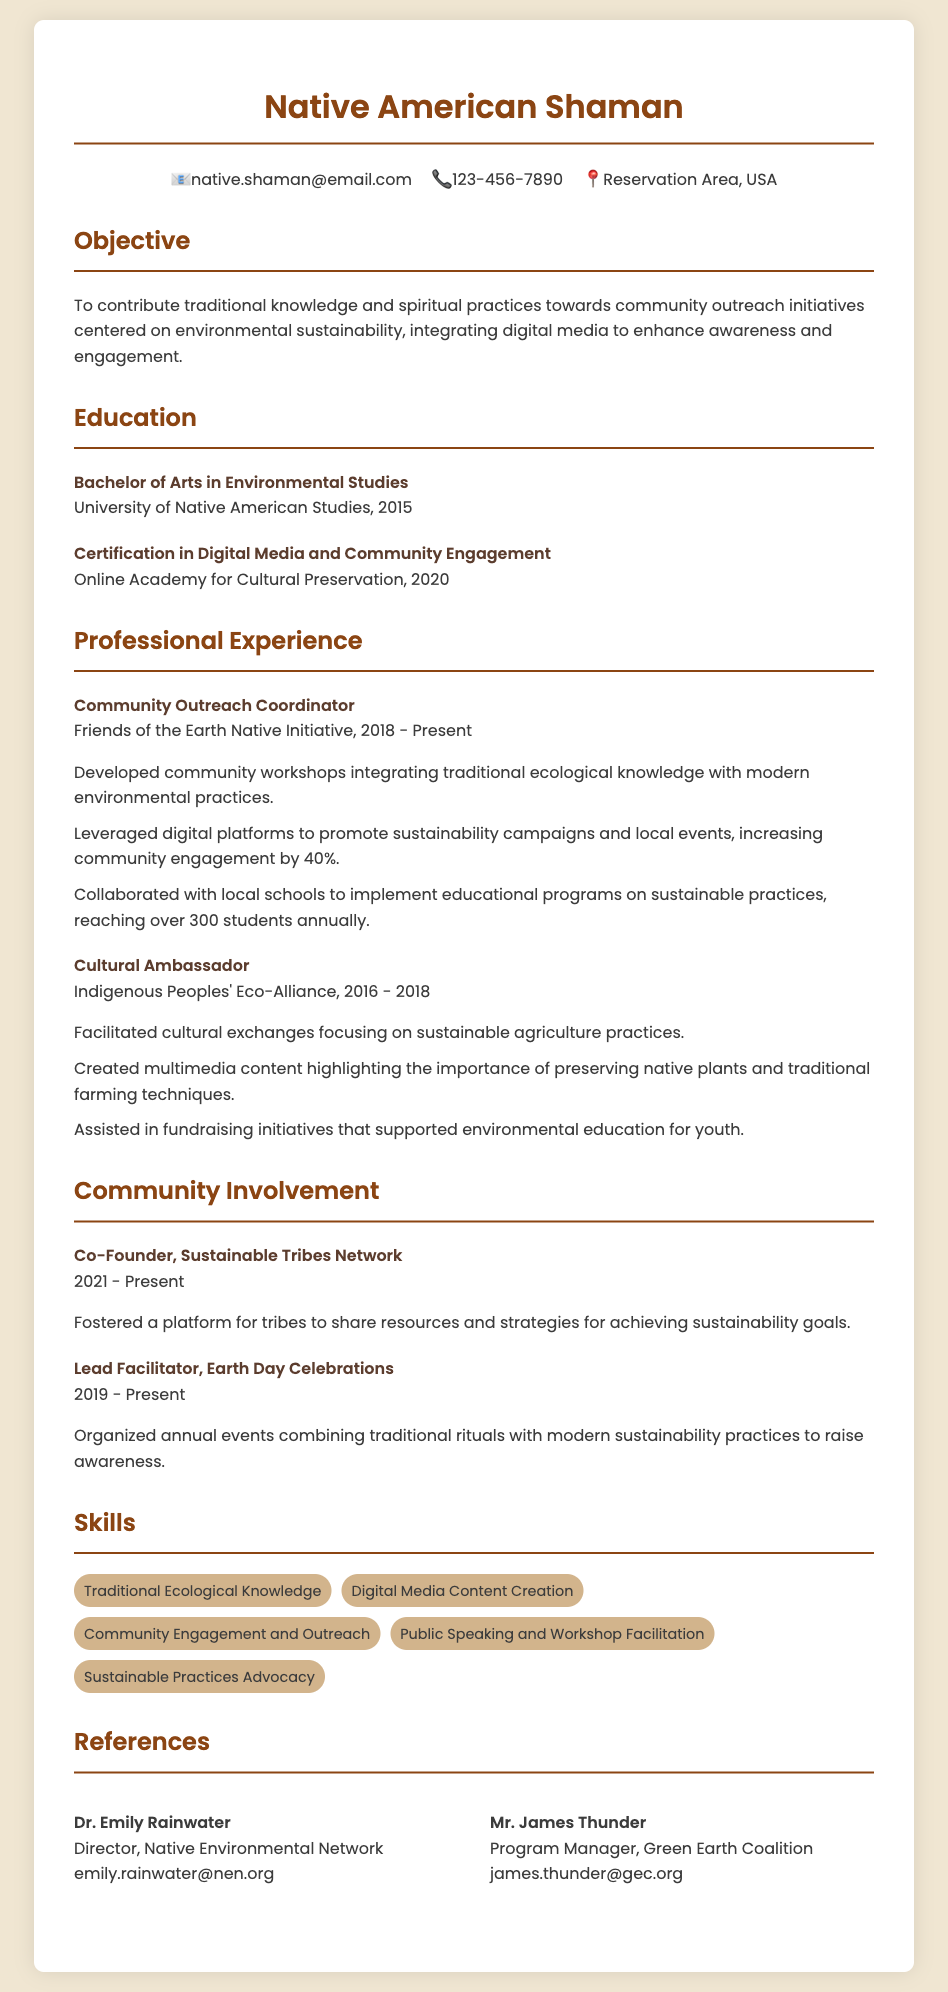What is the title of the document? The title of the document, as indicated in the header, is "Native American Shaman CV."
Answer: Native American Shaman CV What is the email address provided in the contact info? The email address found in the contact info section is used for communication.
Answer: native.shaman@email.com When did the individual graduate with a Bachelor of Arts in Environmental Studies? The year of graduation is stated in the education section of the document.
Answer: 2015 What organization is the individual currently working for as a Community Outreach Coordinator? The name of the organization employs the individual in the specific role mentioned.
Answer: Friends of the Earth Native Initiative How much did community engagement increase due to digital platforms? The percentage increase in community engagement due to initiatives is mentioned in the professional experience section.
Answer: 40% What initiative did the individual co-found? This question pertains to a key project mentioned in community involvement.
Answer: Sustainable Tribes Network What type of skills does the individual possess according to the document? The section provides several specific skills relevant to the individual's experience.
Answer: Traditional Ecological Knowledge In which year did the individual start working as a Cultural Ambassador? This refers to the beginning of the experience in a specific title in the document.
Answer: 2016 Who is Dr. Emily Rainwater? The document introduces this person in the references section, detailing their role.
Answer: Director, Native Environmental Network 